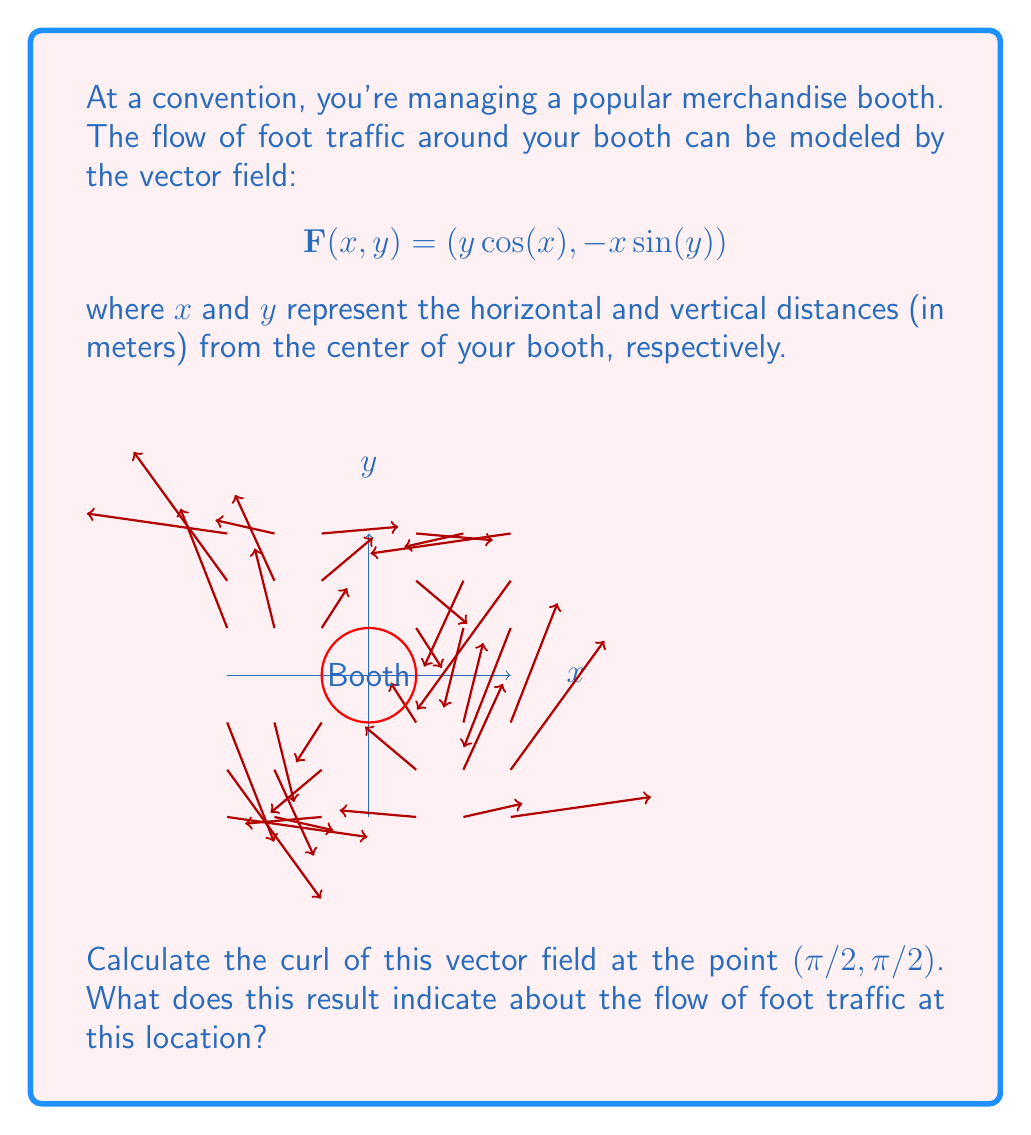Can you solve this math problem? Let's approach this step-by-step:

1) The curl of a vector field $\mathbf{F}(x,y) = (P(x,y), Q(x,y))$ in two dimensions is given by:

   $$\text{curl } \mathbf{F} = \frac{\partial Q}{\partial x} - \frac{\partial P}{\partial y}$$

2) In our case, $P(x,y) = y\cos(x)$ and $Q(x,y) = -x\sin(y)$

3) Let's calculate the partial derivatives:

   $$\frac{\partial Q}{\partial x} = -\sin(y)$$
   
   $$\frac{\partial P}{\partial y} = \cos(x)$$

4) Now we can calculate the curl:

   $$\text{curl } \mathbf{F} = -\sin(y) - \cos(x)$$

5) We need to evaluate this at the point (π/2, π/2):

   $$\text{curl } \mathbf{F}(\frac{\pi}{2}, \frac{\pi}{2}) = -\sin(\frac{\pi}{2}) - \cos(\frac{\pi}{2}) = -1 - 0 = -1$$

6) Interpretation: The negative curl indicates that the foot traffic at this point has a clockwise rotational tendency. The magnitude of 1 suggests a moderate strength to this rotation.

For a merchandise vendor, this means that at the point (π/2, π/2) relative to your booth, visitors tend to move in a clockwise direction around your booth. This could influence how you arrange your displays or manage queues to optimize traffic flow and visibility of your merchandise.
Answer: $-1$; clockwise rotation of foot traffic 